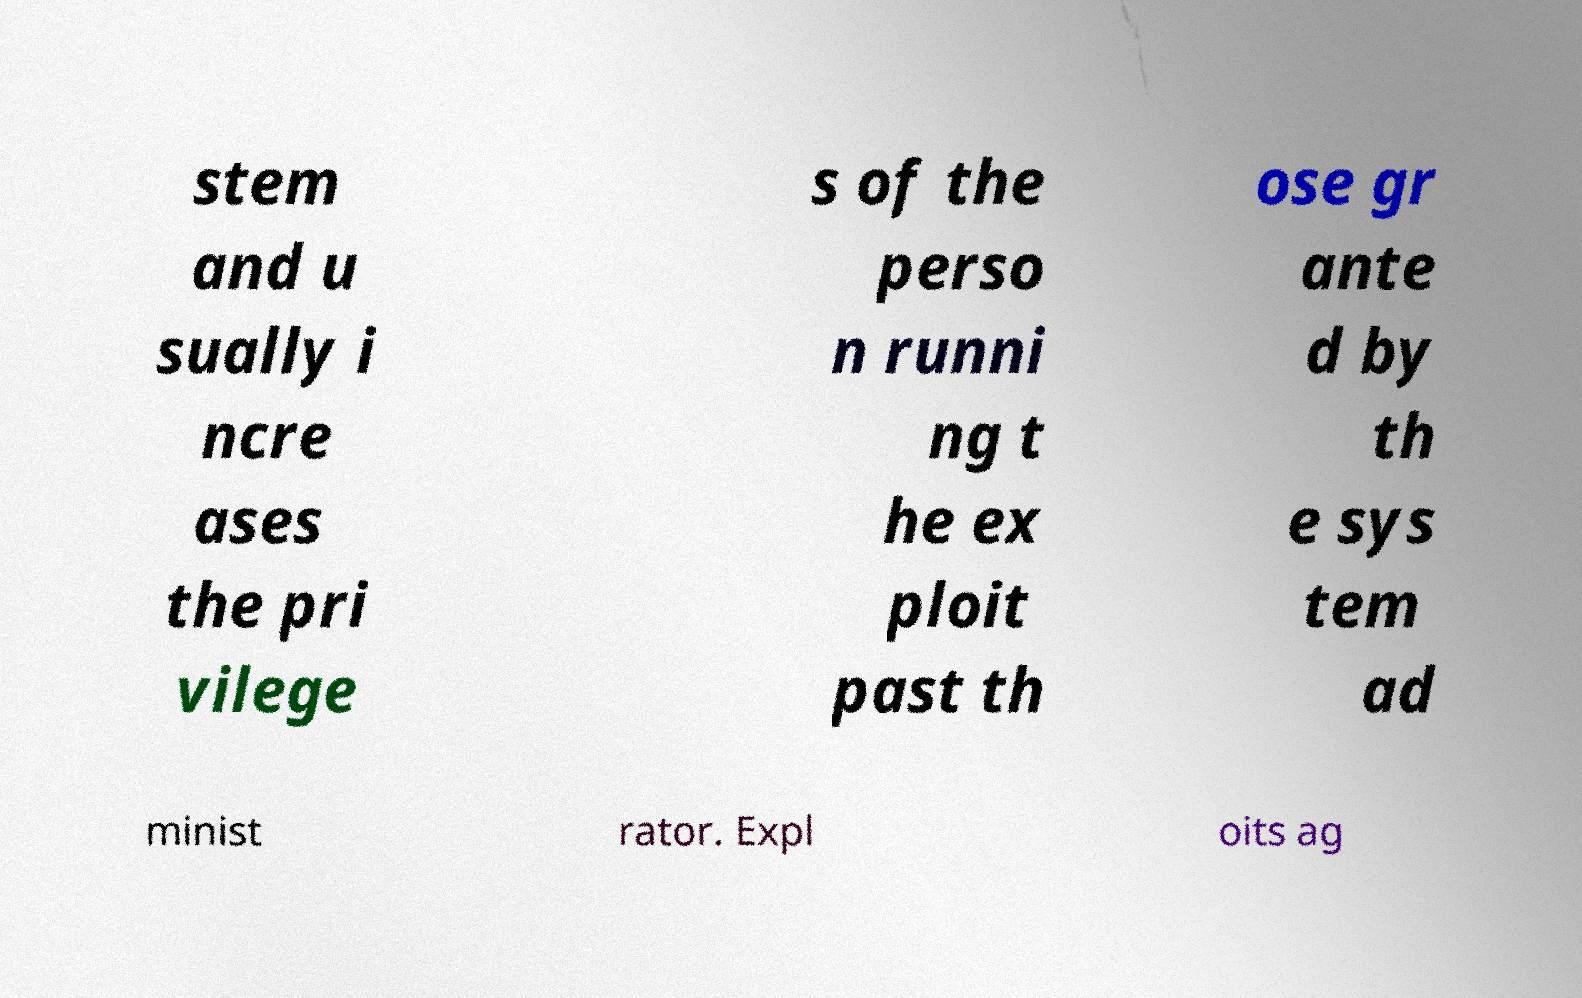Please read and relay the text visible in this image. What does it say? stem and u sually i ncre ases the pri vilege s of the perso n runni ng t he ex ploit past th ose gr ante d by th e sys tem ad minist rator. Expl oits ag 